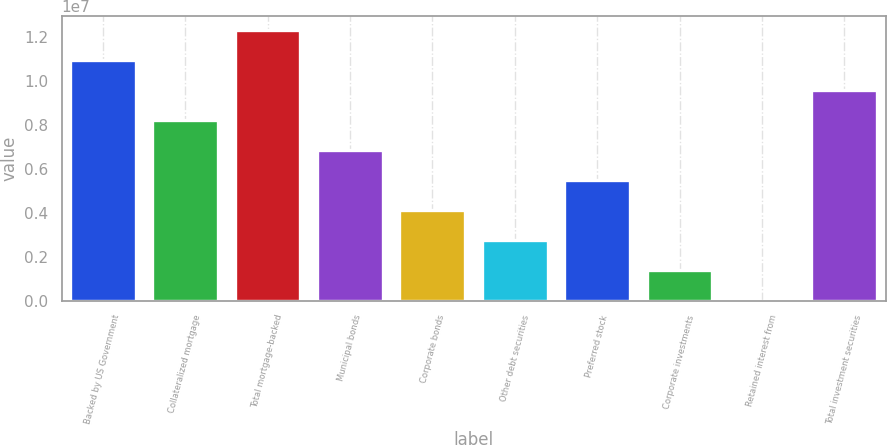Convert chart. <chart><loc_0><loc_0><loc_500><loc_500><bar_chart><fcel>Backed by US Government<fcel>Collateralized mortgage<fcel>Total mortgage-backed<fcel>Municipal bonds<fcel>Corporate bonds<fcel>Other debt securities<fcel>Preferred stock<fcel>Corporate investments<fcel>Retained interest from<fcel>Total investment securities<nl><fcel>1.09429e+07<fcel>8.20802e+06<fcel>1.23103e+07<fcel>6.84058e+06<fcel>4.10571e+06<fcel>2.73827e+06<fcel>5.47314e+06<fcel>1.37083e+06<fcel>3393<fcel>9.57546e+06<nl></chart> 